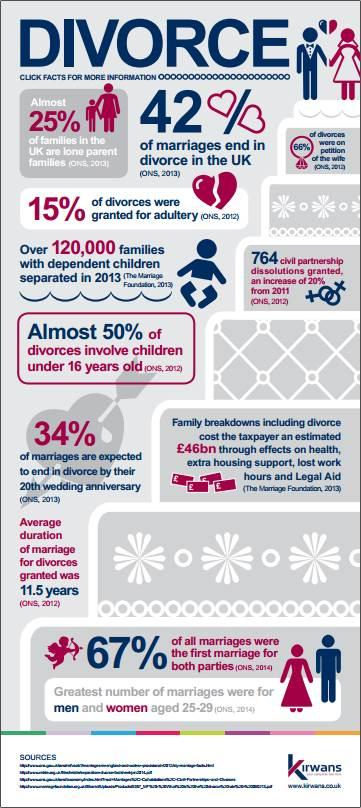Identify some key points in this picture. According to statistics, 85% of divorces among adults are allowed. According to a recent survey, approximately 58% of marriages in the UK are considered successful. According to a recent study in the UK, approximately 42% of marriages end in separation, indicating a high rate of unsuccessful marriages. 